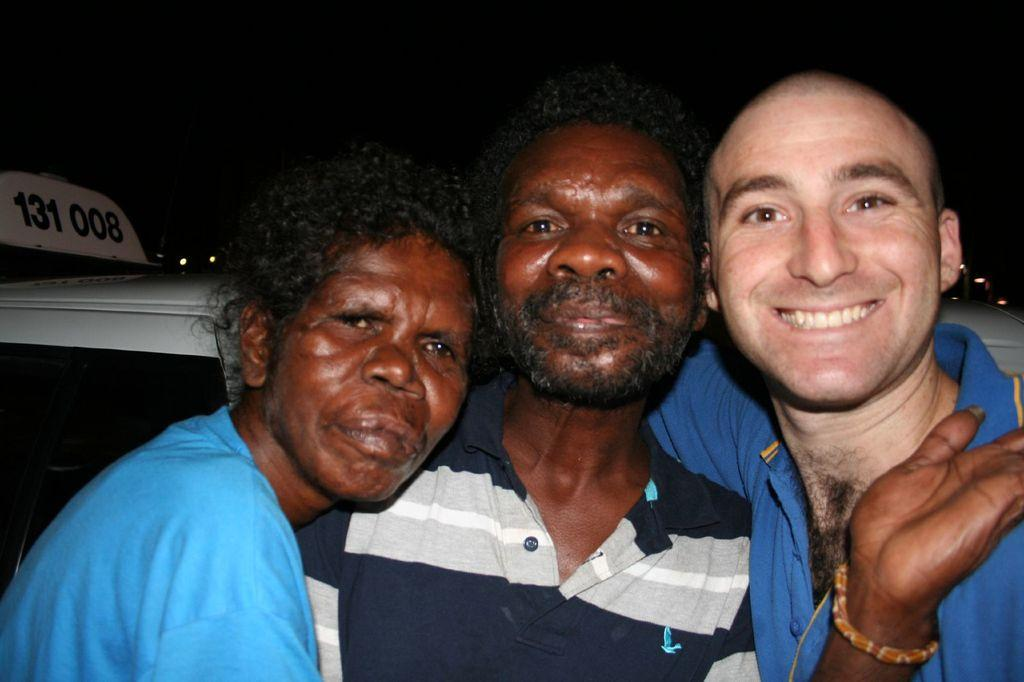How many people are in the image? There are three persons in the image. What can be seen in the background of the image? There is a vehicle in the background. Where is the number located in the image? The number is on the left side of the image. How would you describe the lighting in the image? The background of the image is dark. What type of chalk is being used by the goose in the image? There is no goose or chalk present in the image. Is there a curtain visible in the image? No, there is no curtain visible in the image. 